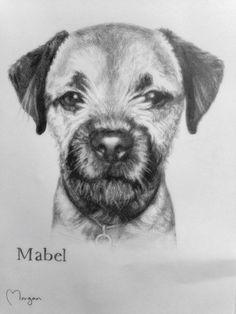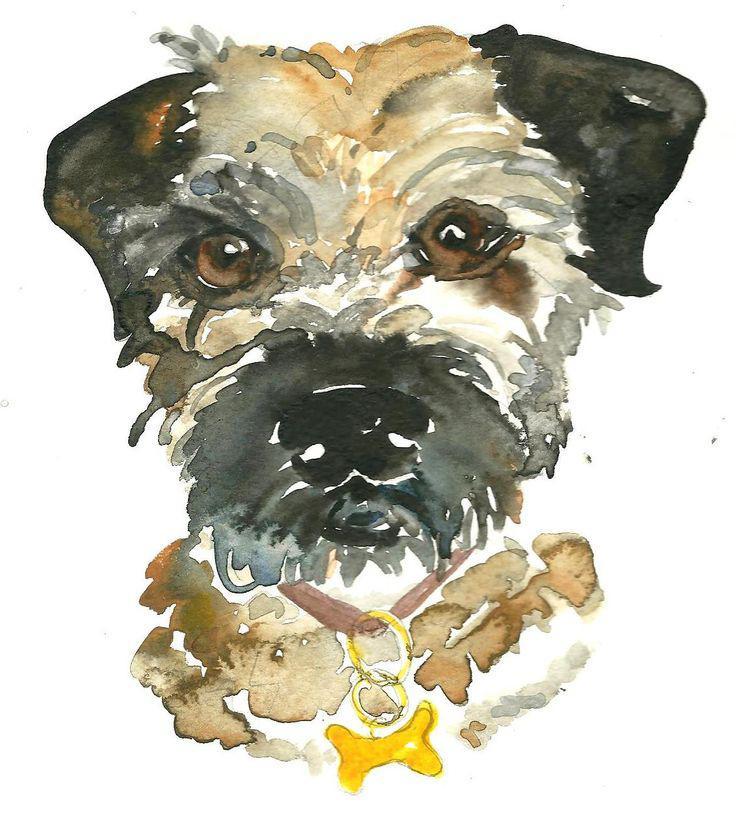The first image is the image on the left, the second image is the image on the right. For the images shown, is this caption "A black and tan dog has snow on its face." true? Answer yes or no. No. 